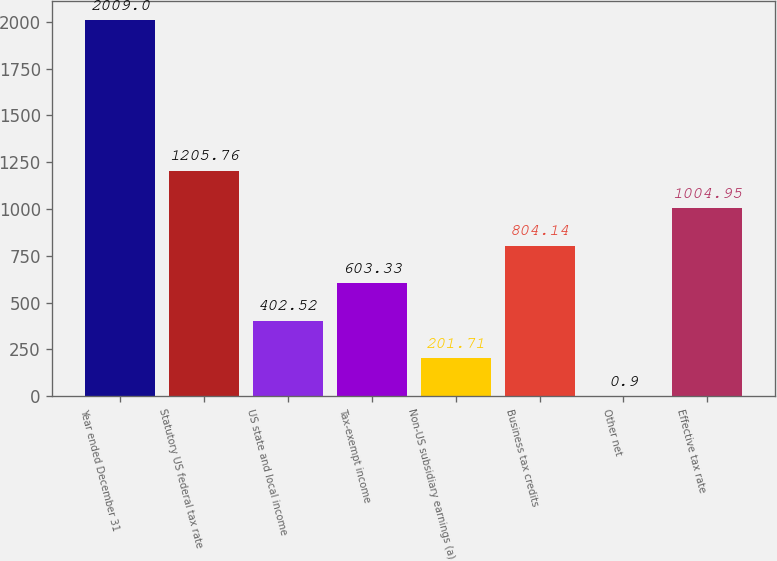Convert chart. <chart><loc_0><loc_0><loc_500><loc_500><bar_chart><fcel>Year ended December 31<fcel>Statutory US federal tax rate<fcel>US state and local income<fcel>Tax-exempt income<fcel>Non-US subsidiary earnings (a)<fcel>Business tax credits<fcel>Other net<fcel>Effective tax rate<nl><fcel>2009<fcel>1205.76<fcel>402.52<fcel>603.33<fcel>201.71<fcel>804.14<fcel>0.9<fcel>1004.95<nl></chart> 